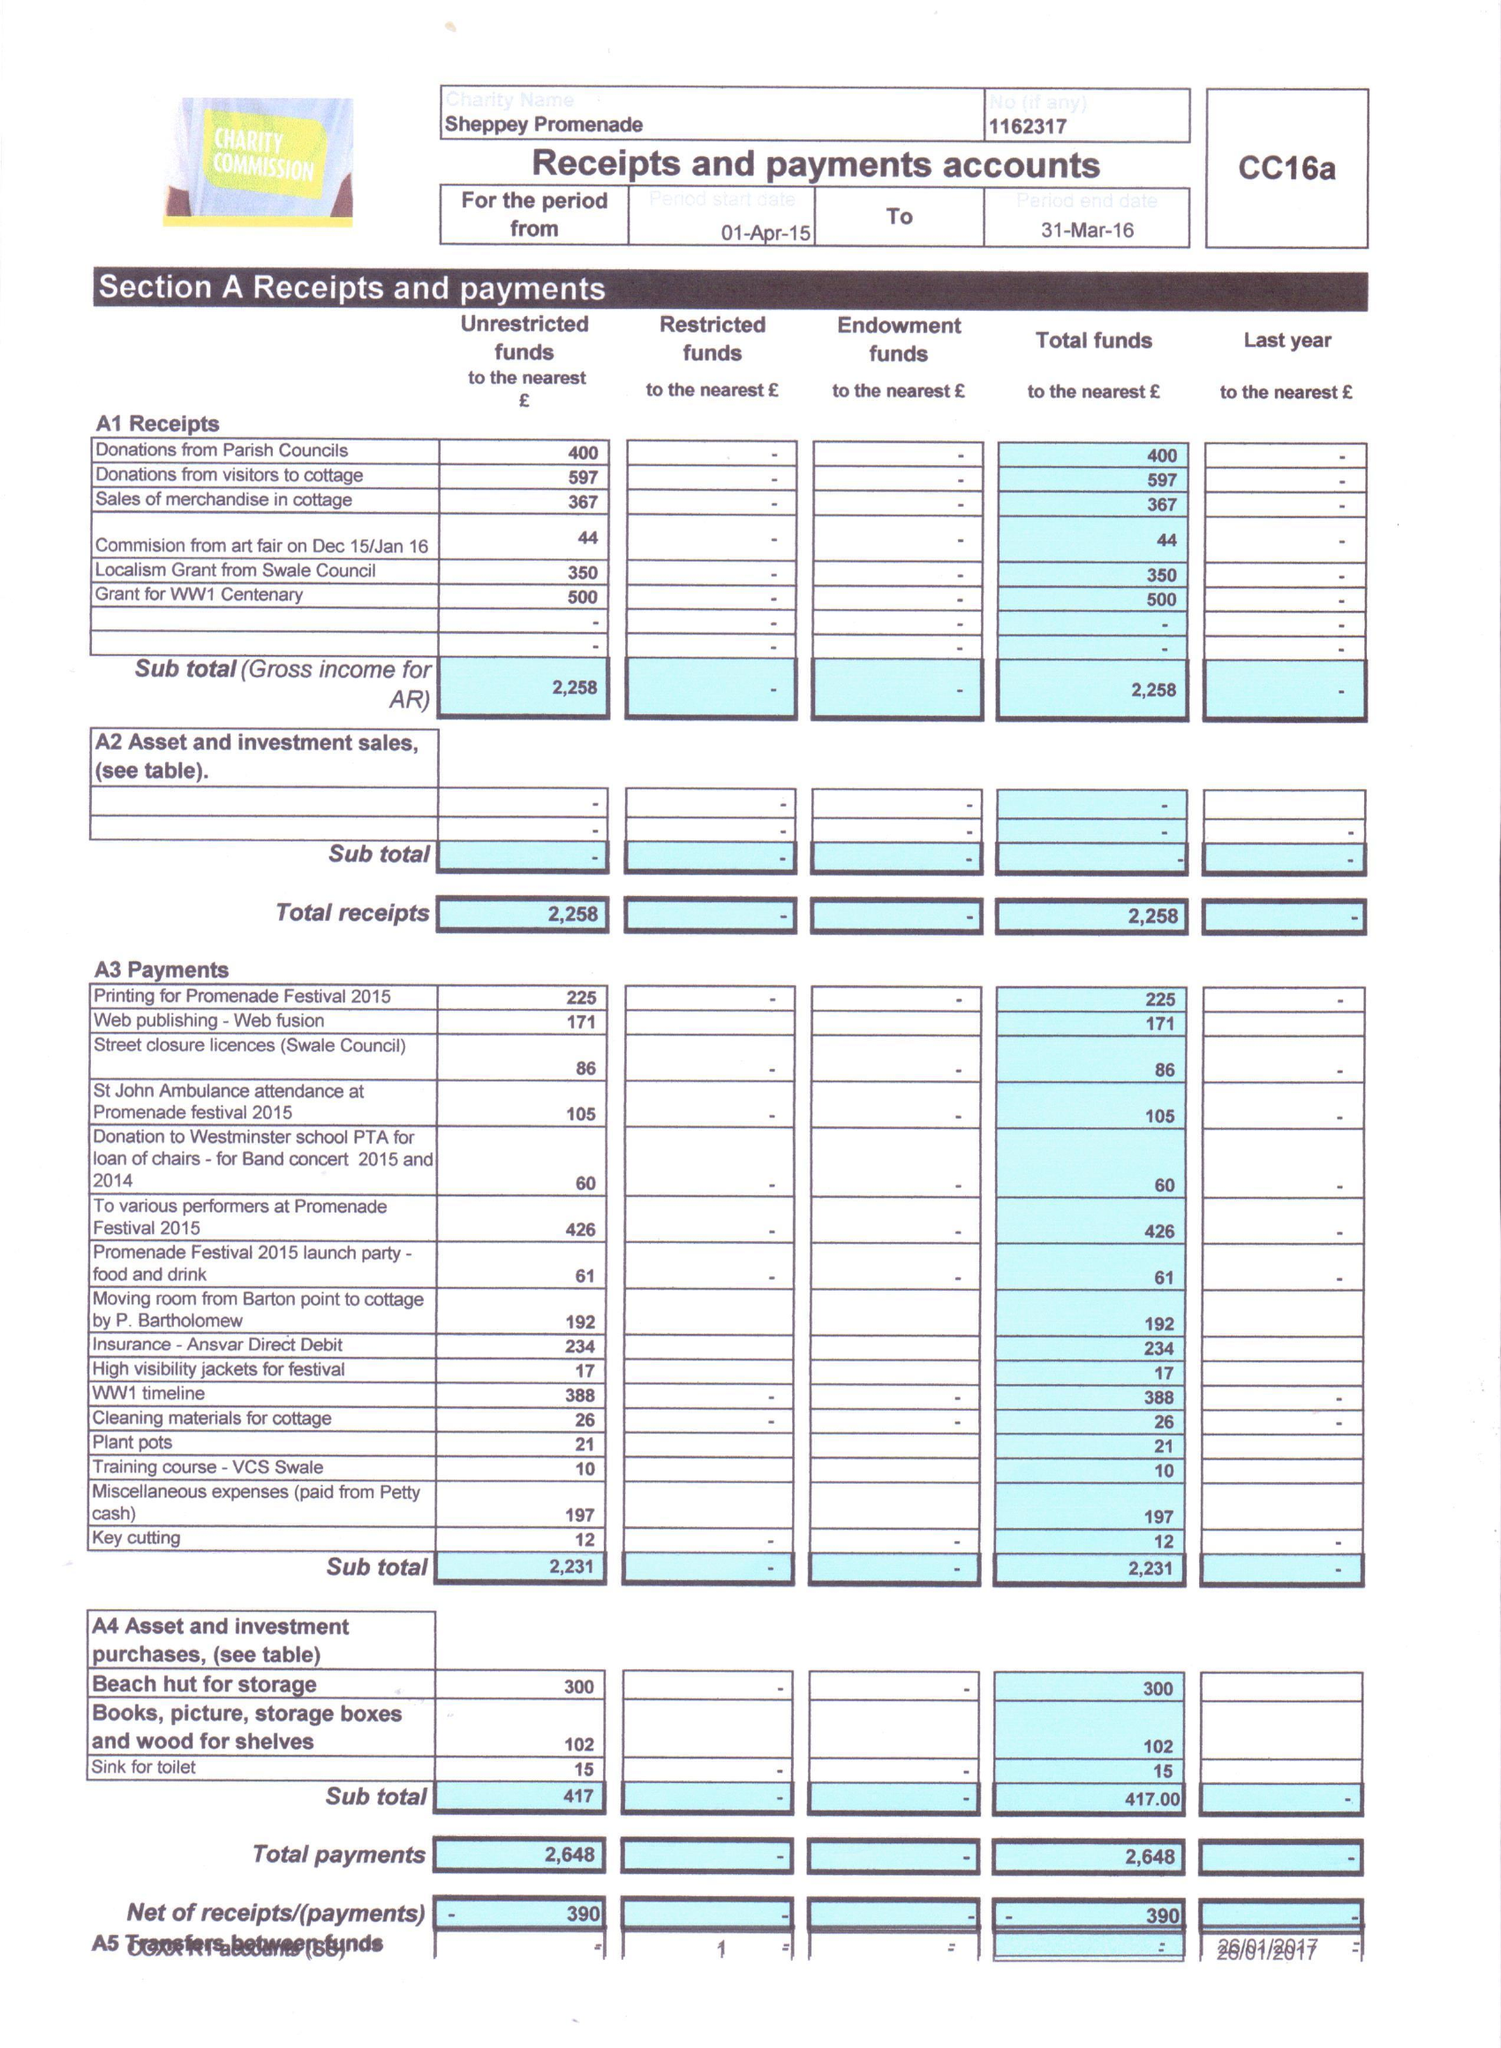What is the value for the charity_number?
Answer the question using a single word or phrase. 1162317 